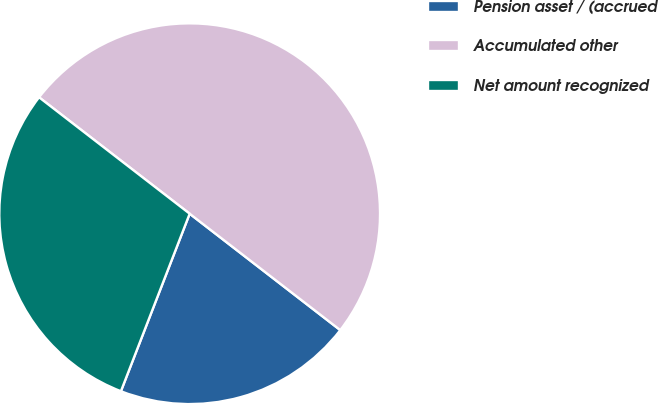Convert chart. <chart><loc_0><loc_0><loc_500><loc_500><pie_chart><fcel>Pension asset / (accrued<fcel>Accumulated other<fcel>Net amount recognized<nl><fcel>20.41%<fcel>50.0%<fcel>29.59%<nl></chart> 